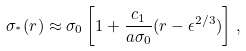<formula> <loc_0><loc_0><loc_500><loc_500>\sigma _ { ^ { * } } ( r ) \approx \sigma _ { 0 } \left [ 1 + \frac { c _ { 1 } } { a \sigma _ { 0 } } ( r - \epsilon ^ { 2 / 3 } ) \right ] \, ,</formula> 